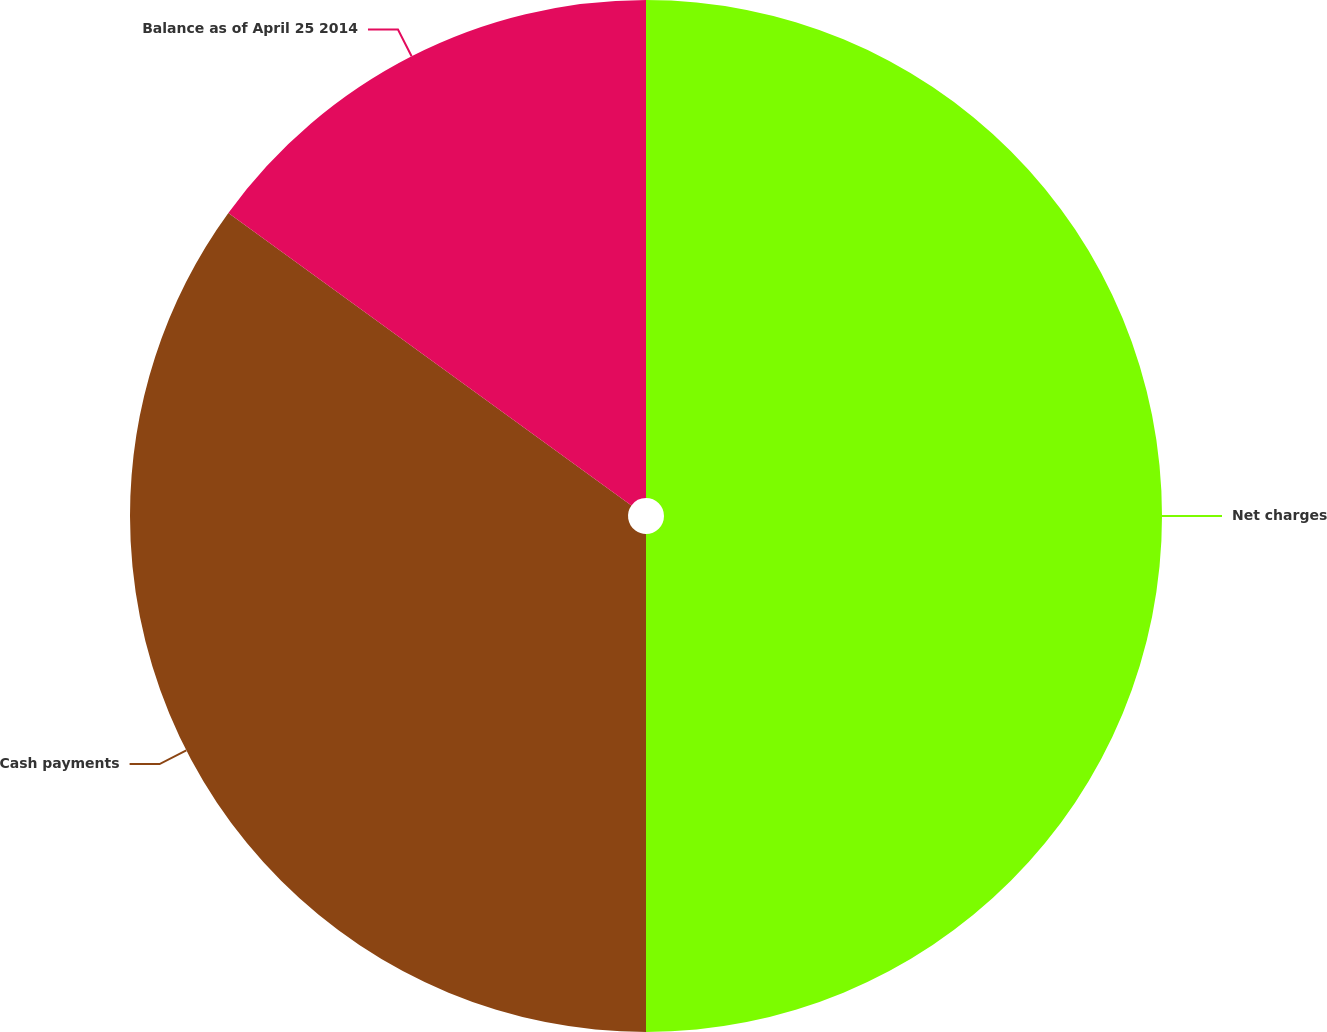Convert chart to OTSL. <chart><loc_0><loc_0><loc_500><loc_500><pie_chart><fcel>Net charges<fcel>Cash payments<fcel>Balance as of April 25 2014<nl><fcel>50.0%<fcel>34.99%<fcel>15.01%<nl></chart> 